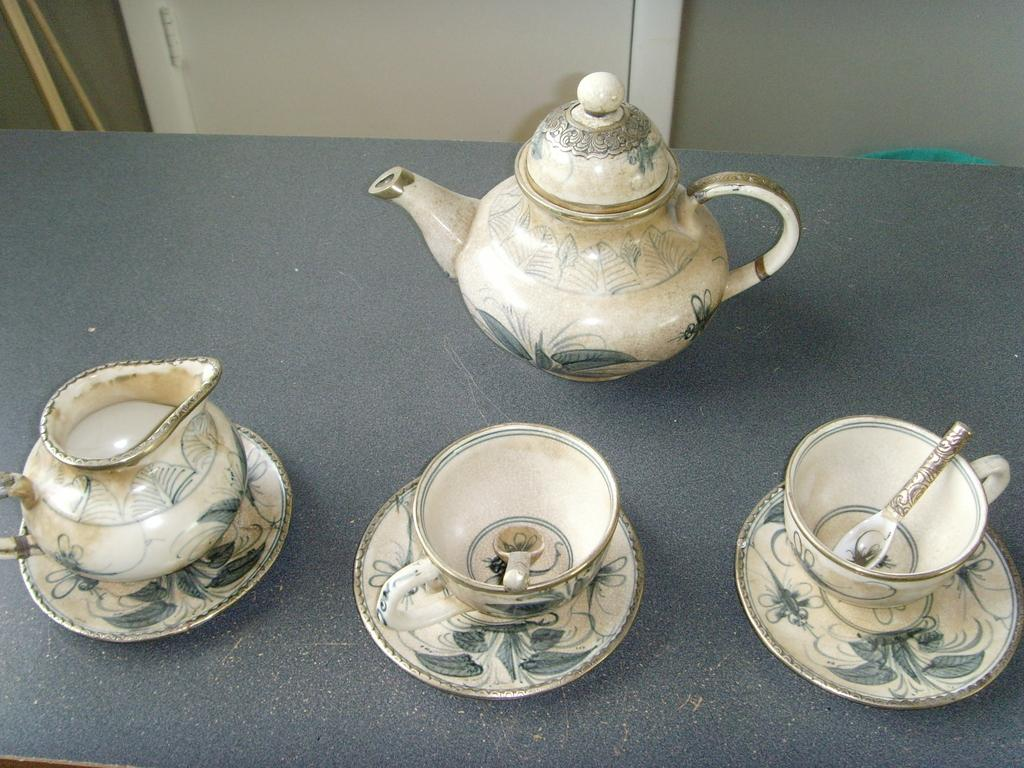What is the main object in the image? There is a kettle in the image. What other objects are present with the kettle? There are cups and saucers in the image. What color is the surface on which the objects are placed? The objects are on a black color surface. What type of gun is present on the black surface in the image? There is no gun present on the black surface in the image; only a kettle, cups, and saucers are visible. 